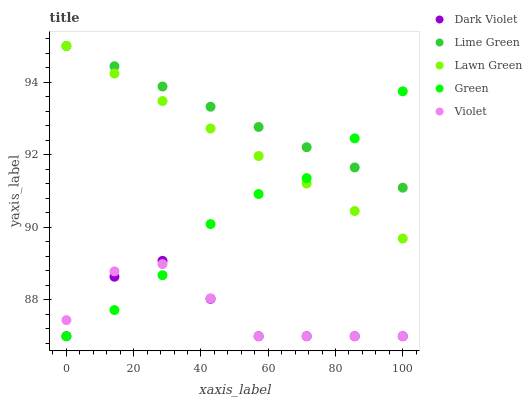Does Dark Violet have the minimum area under the curve?
Answer yes or no. Yes. Does Lime Green have the maximum area under the curve?
Answer yes or no. Yes. Does Green have the minimum area under the curve?
Answer yes or no. No. Does Green have the maximum area under the curve?
Answer yes or no. No. Is Lawn Green the smoothest?
Answer yes or no. Yes. Is Dark Violet the roughest?
Answer yes or no. Yes. Is Green the smoothest?
Answer yes or no. No. Is Green the roughest?
Answer yes or no. No. Does Green have the lowest value?
Answer yes or no. Yes. Does Lime Green have the lowest value?
Answer yes or no. No. Does Lime Green have the highest value?
Answer yes or no. Yes. Does Green have the highest value?
Answer yes or no. No. Is Dark Violet less than Lime Green?
Answer yes or no. Yes. Is Lime Green greater than Dark Violet?
Answer yes or no. Yes. Does Green intersect Violet?
Answer yes or no. Yes. Is Green less than Violet?
Answer yes or no. No. Is Green greater than Violet?
Answer yes or no. No. Does Dark Violet intersect Lime Green?
Answer yes or no. No. 